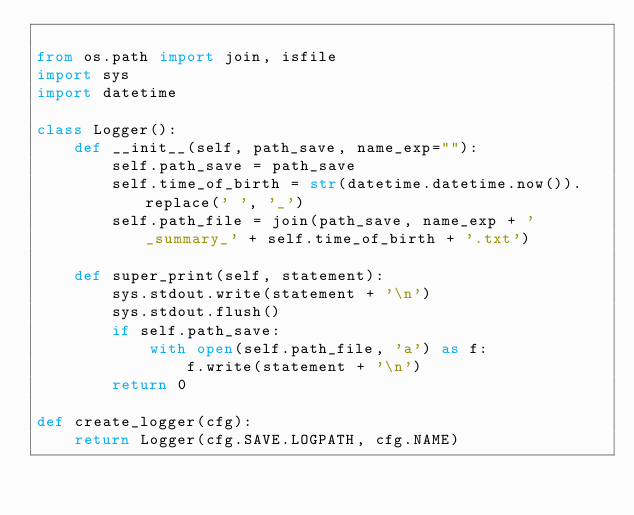Convert code to text. <code><loc_0><loc_0><loc_500><loc_500><_Python_>
from os.path import join, isfile
import sys
import datetime

class Logger():
    def __init__(self, path_save, name_exp=""):
        self.path_save = path_save
        self.time_of_birth = str(datetime.datetime.now()).replace(' ', '_')
        self.path_file = join(path_save, name_exp + '_summary_' + self.time_of_birth + '.txt')

    def super_print(self, statement):
        sys.stdout.write(statement + '\n')
        sys.stdout.flush()
        if self.path_save:
            with open(self.path_file, 'a') as f:
                f.write(statement + '\n')
        return 0

def create_logger(cfg):
    return Logger(cfg.SAVE.LOGPATH, cfg.NAME)
</code> 